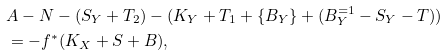Convert formula to latex. <formula><loc_0><loc_0><loc_500><loc_500>& A - N - ( S _ { Y } + T _ { 2 } ) - ( K _ { Y } + T _ { 1 } + \{ B _ { Y } \} + ( B ^ { = 1 } _ { Y } - S _ { Y } - T ) ) \\ & = - f ^ { * } ( K _ { X } + S + B ) ,</formula> 